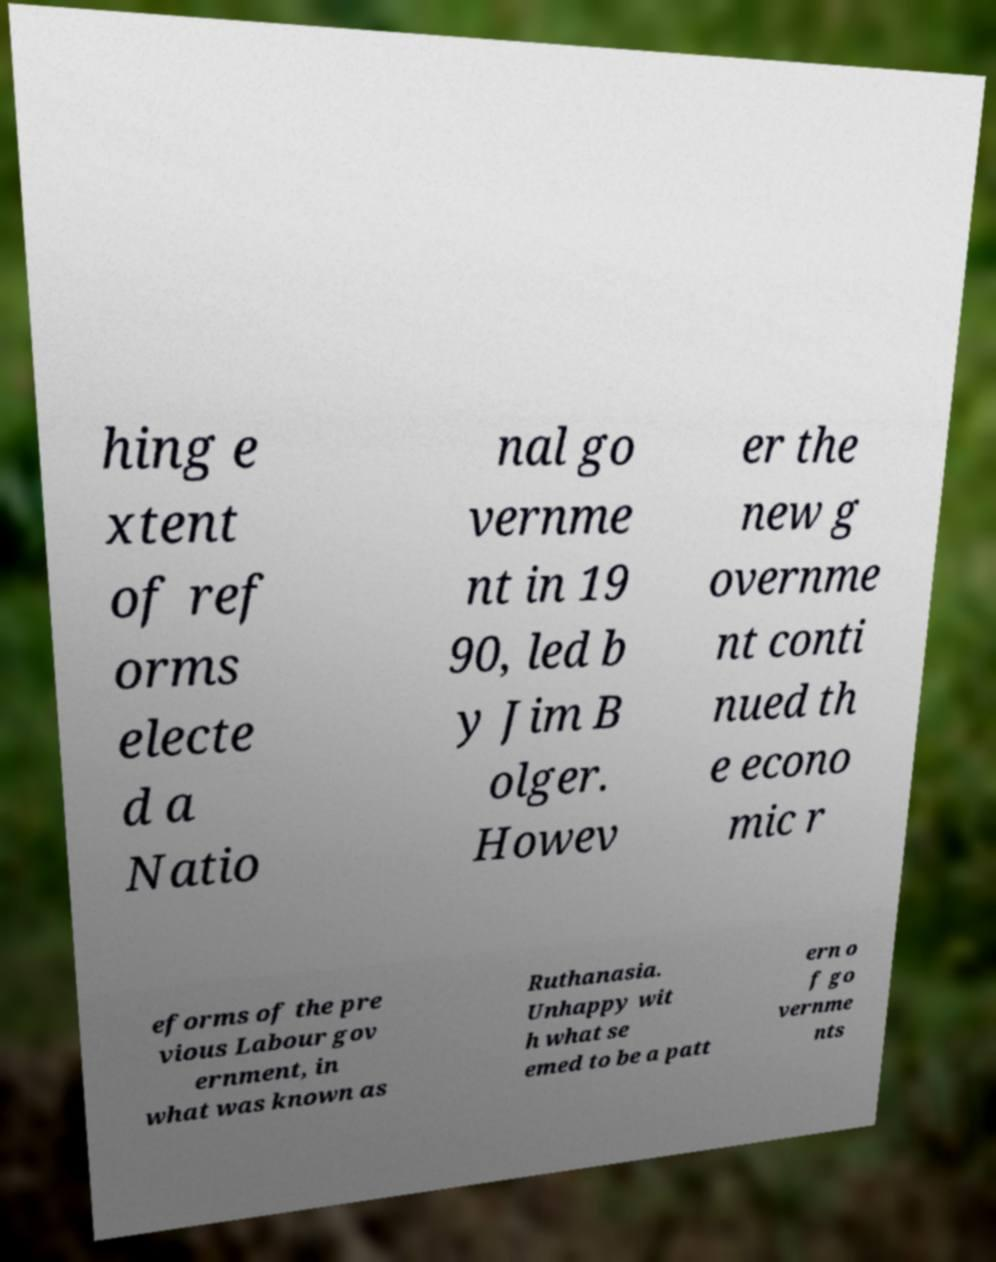I need the written content from this picture converted into text. Can you do that? hing e xtent of ref orms electe d a Natio nal go vernme nt in 19 90, led b y Jim B olger. Howev er the new g overnme nt conti nued th e econo mic r eforms of the pre vious Labour gov ernment, in what was known as Ruthanasia. Unhappy wit h what se emed to be a patt ern o f go vernme nts 